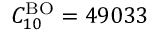<formula> <loc_0><loc_0><loc_500><loc_500>C _ { 1 0 } ^ { B O } = 4 9 0 3 3</formula> 